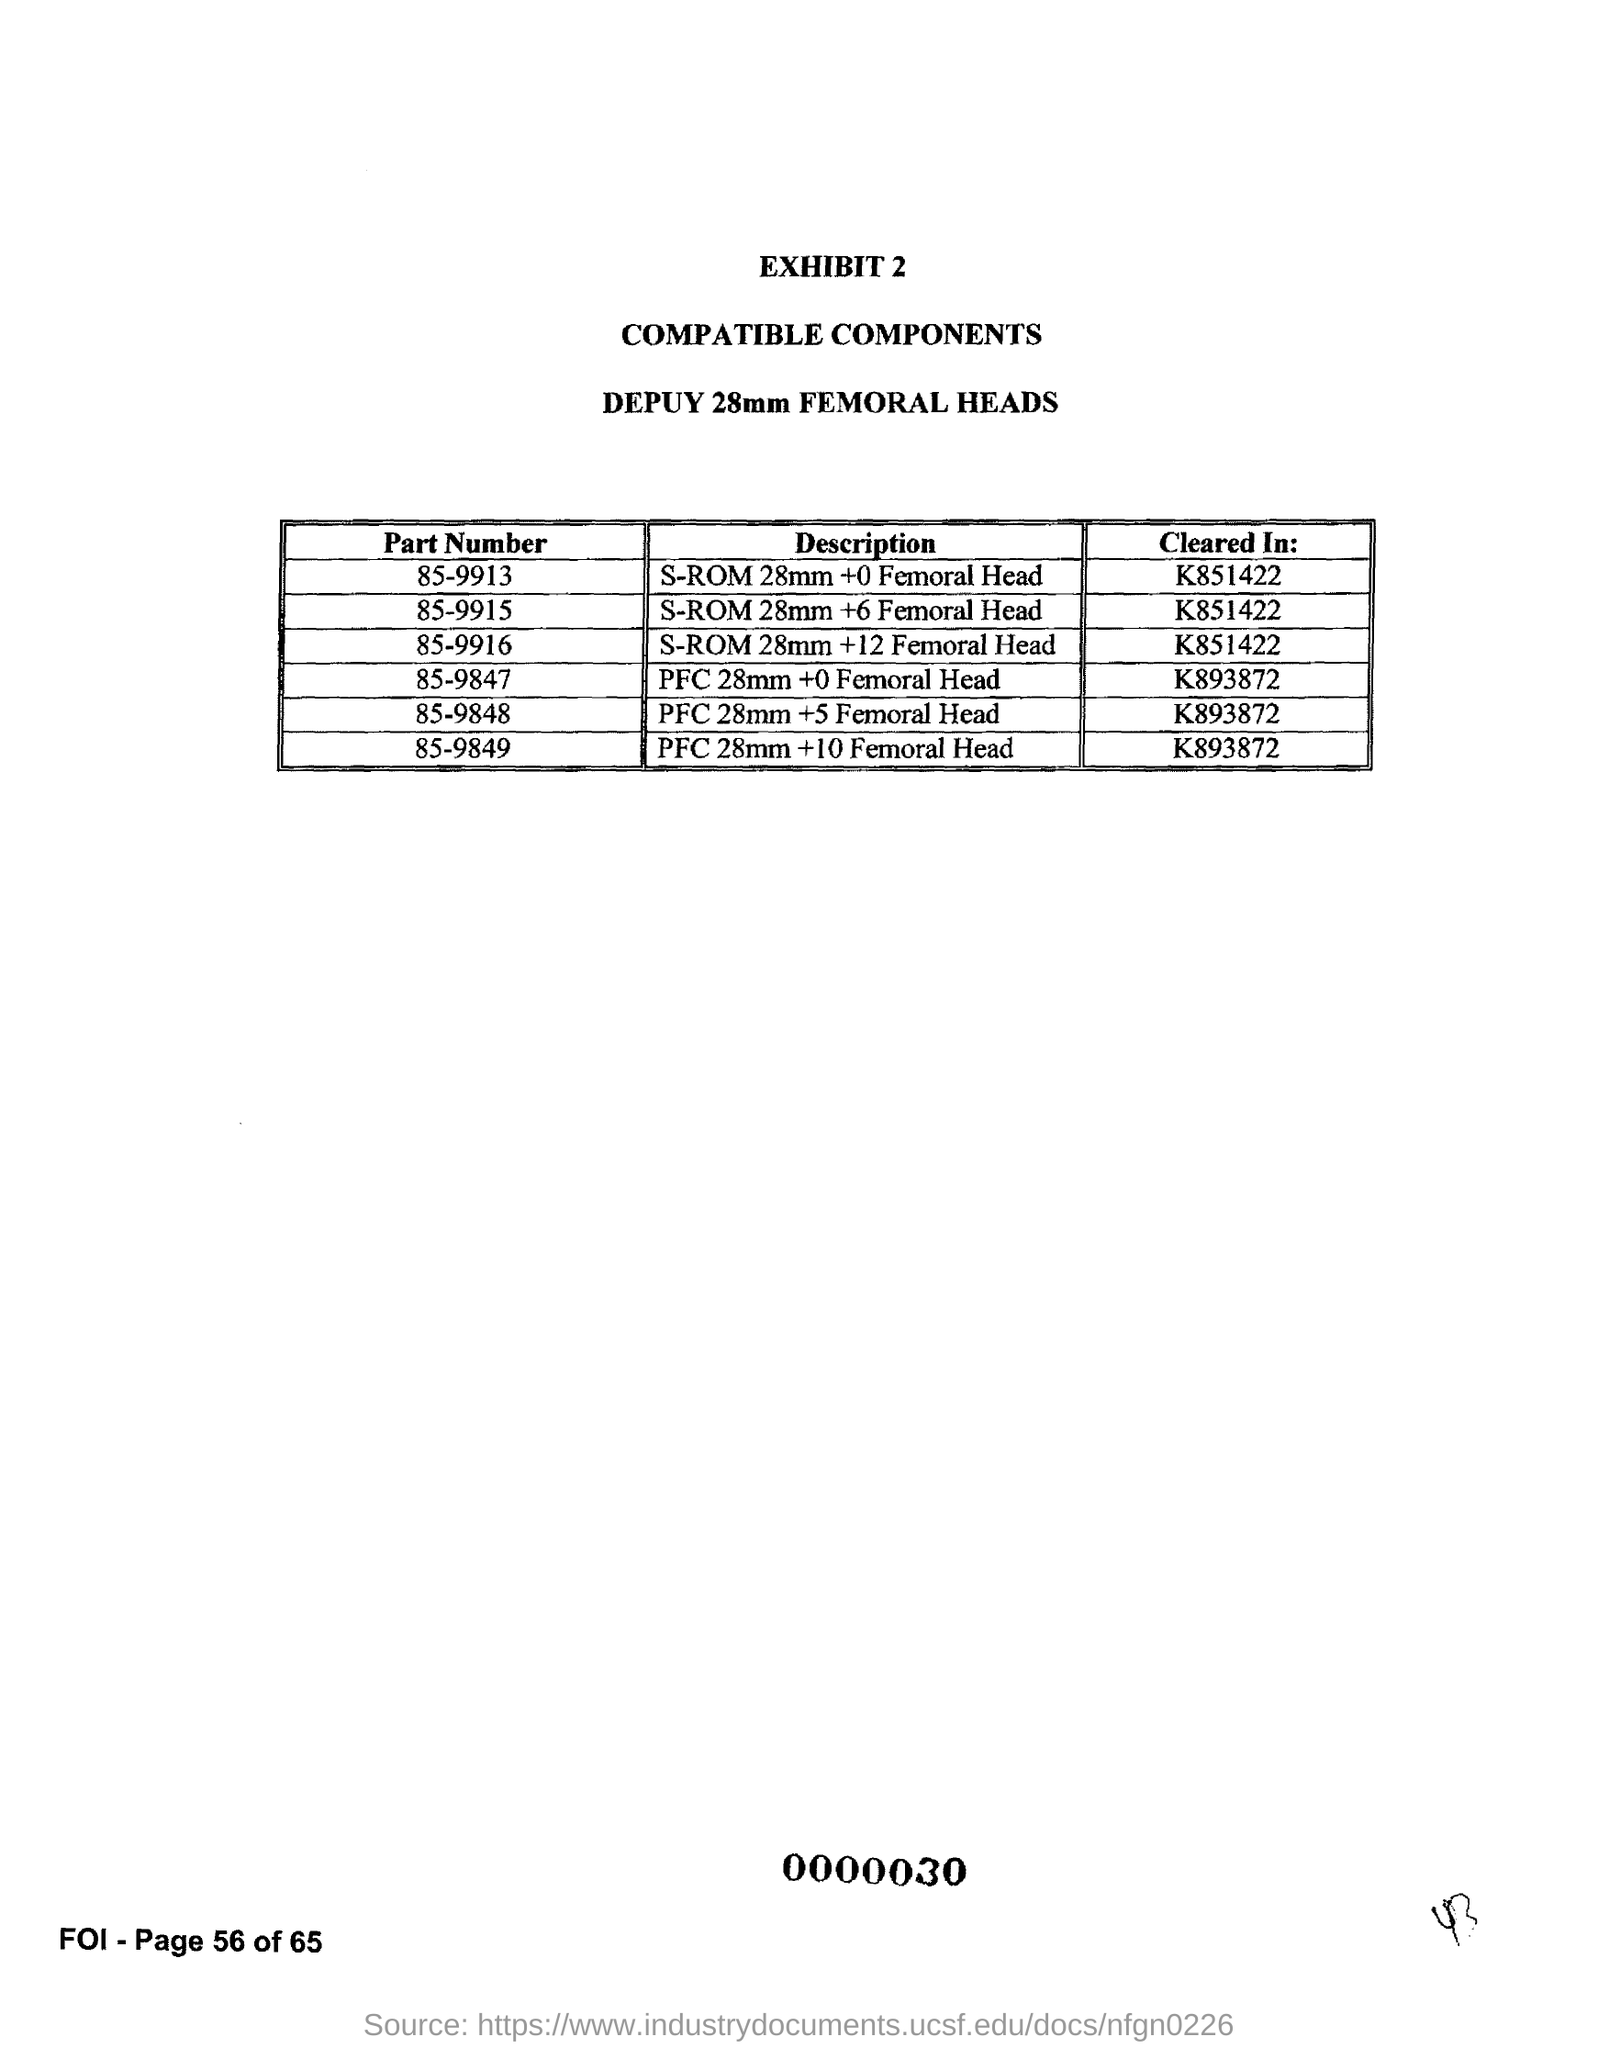What is the Part Number "85-9913" Cleared In?
Offer a very short reply. K851422. What is the Part Number "85-9915" Cleared In?
Your response must be concise. K851422. What is the Part Number "85-9916" Cleared In?
Ensure brevity in your answer.  K851422. What is the Part Number "85-9847" Cleared In?
Provide a succinct answer. K893872. What is the "Cleared In"" of  Part Number - "85-9848"?
Provide a succinct answer. K893872. What is the "Cleared In" of part number - "85-9849" ?
Provide a short and direct response. K893872. What is the Part Number "85-9913" Description?
Give a very brief answer. S-ROM 28mm +0 Femoral Head. What is the Part Number "85-9915" Description?
Your answer should be compact. S-ROM 28mm +6 Femoral Head. What is the Part Number "85-9916" Description?
Give a very brief answer. S-ROM 28mm +12 Femoral Head. What is the Page Number?
Provide a succinct answer. Page 56 of 65. 